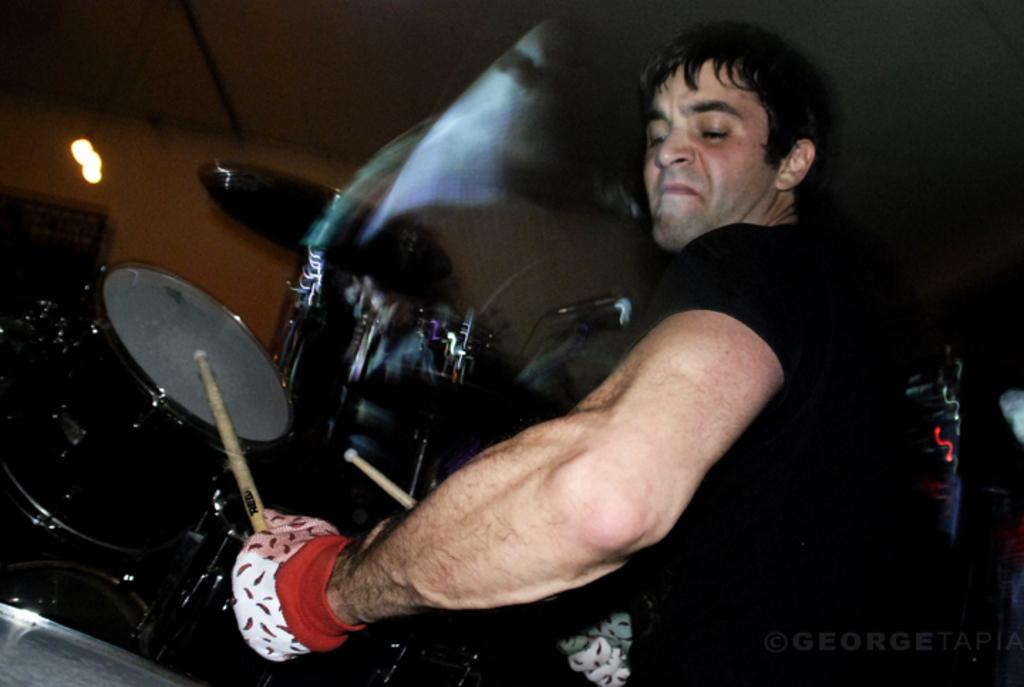What is the main subject of the image? The main subject of the image is a man. What is the man wearing in the image? The man is wearing a black t-shirt in the image. What activity is the man engaged in? The man is playing musical drums in the image. What type of sweater is the man wearing in the image? The man is not wearing a sweater in the image; he is wearing a black t-shirt. What instrument is the man using to measure the distance between two points in the image? There is no instrument for measuring distances present in the image, and the man is playing musical drums, not measuring distances. 